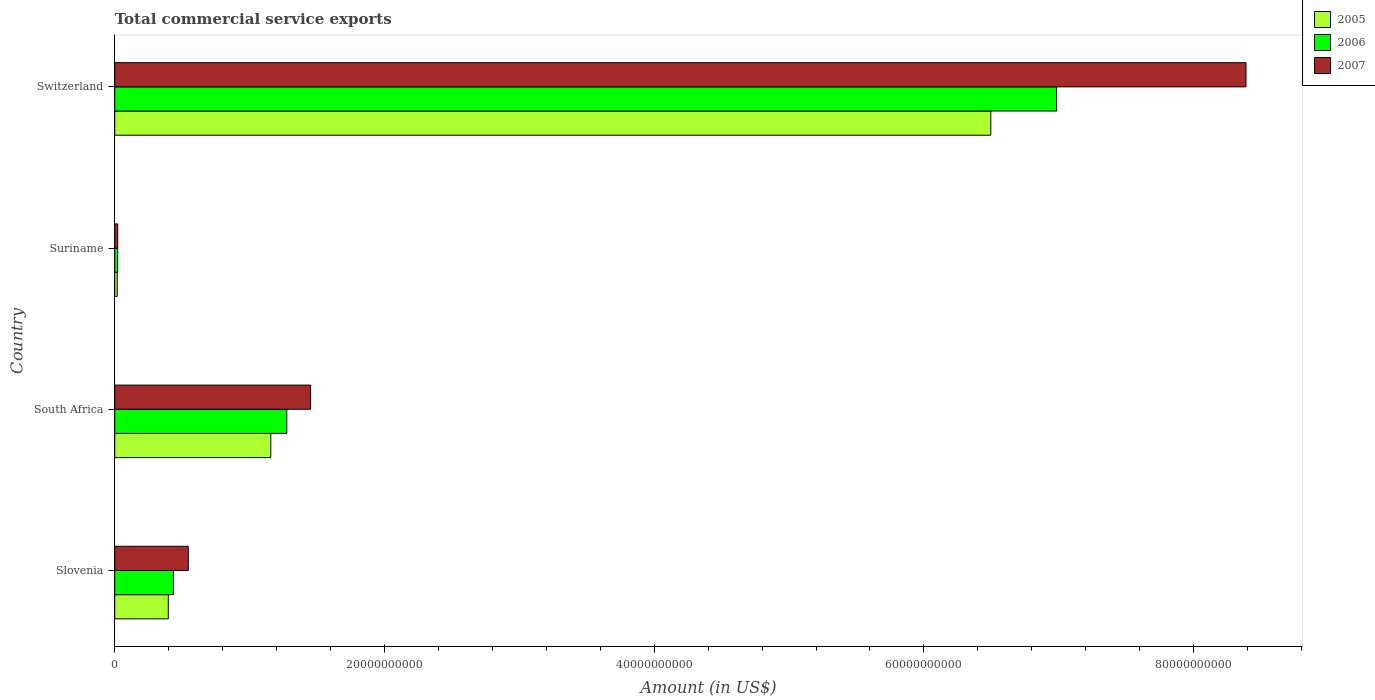How many different coloured bars are there?
Provide a succinct answer. 3. How many groups of bars are there?
Make the answer very short. 4. Are the number of bars on each tick of the Y-axis equal?
Provide a short and direct response. Yes. What is the label of the 2nd group of bars from the top?
Ensure brevity in your answer.  Suriname. What is the total commercial service exports in 2007 in Switzerland?
Keep it short and to the point. 8.39e+1. Across all countries, what is the maximum total commercial service exports in 2006?
Offer a terse response. 6.98e+1. Across all countries, what is the minimum total commercial service exports in 2007?
Give a very brief answer. 2.19e+08. In which country was the total commercial service exports in 2007 maximum?
Provide a succinct answer. Switzerland. In which country was the total commercial service exports in 2005 minimum?
Offer a terse response. Suriname. What is the total total commercial service exports in 2007 in the graph?
Give a very brief answer. 1.04e+11. What is the difference between the total commercial service exports in 2005 in South Africa and that in Suriname?
Your answer should be compact. 1.14e+1. What is the difference between the total commercial service exports in 2007 in Slovenia and the total commercial service exports in 2005 in Suriname?
Your response must be concise. 5.27e+09. What is the average total commercial service exports in 2006 per country?
Offer a very short reply. 2.18e+1. What is the difference between the total commercial service exports in 2006 and total commercial service exports in 2007 in Suriname?
Offer a terse response. -5.10e+06. In how many countries, is the total commercial service exports in 2007 greater than 20000000000 US$?
Offer a terse response. 1. What is the ratio of the total commercial service exports in 2007 in Suriname to that in Switzerland?
Offer a terse response. 0. Is the total commercial service exports in 2007 in Slovenia less than that in Switzerland?
Your answer should be compact. Yes. Is the difference between the total commercial service exports in 2006 in Slovenia and Switzerland greater than the difference between the total commercial service exports in 2007 in Slovenia and Switzerland?
Provide a succinct answer. Yes. What is the difference between the highest and the second highest total commercial service exports in 2005?
Your answer should be compact. 5.34e+1. What is the difference between the highest and the lowest total commercial service exports in 2007?
Offer a terse response. 8.37e+1. In how many countries, is the total commercial service exports in 2005 greater than the average total commercial service exports in 2005 taken over all countries?
Your answer should be very brief. 1. Is the sum of the total commercial service exports in 2005 in Suriname and Switzerland greater than the maximum total commercial service exports in 2007 across all countries?
Your answer should be compact. No. What does the 1st bar from the top in Suriname represents?
Give a very brief answer. 2007. What does the 2nd bar from the bottom in Slovenia represents?
Ensure brevity in your answer.  2006. What is the difference between two consecutive major ticks on the X-axis?
Your response must be concise. 2.00e+1. Does the graph contain any zero values?
Make the answer very short. No. Does the graph contain grids?
Give a very brief answer. No. Where does the legend appear in the graph?
Keep it short and to the point. Top right. How are the legend labels stacked?
Give a very brief answer. Vertical. What is the title of the graph?
Provide a short and direct response. Total commercial service exports. Does "1994" appear as one of the legend labels in the graph?
Keep it short and to the point. No. What is the Amount (in US$) in 2005 in Slovenia?
Offer a terse response. 3.97e+09. What is the Amount (in US$) of 2006 in Slovenia?
Your answer should be compact. 4.35e+09. What is the Amount (in US$) of 2007 in Slovenia?
Give a very brief answer. 5.45e+09. What is the Amount (in US$) of 2005 in South Africa?
Provide a short and direct response. 1.16e+1. What is the Amount (in US$) of 2006 in South Africa?
Your answer should be very brief. 1.28e+1. What is the Amount (in US$) in 2007 in South Africa?
Give a very brief answer. 1.45e+1. What is the Amount (in US$) in 2005 in Suriname?
Offer a terse response. 1.83e+08. What is the Amount (in US$) of 2006 in Suriname?
Offer a very short reply. 2.14e+08. What is the Amount (in US$) in 2007 in Suriname?
Your answer should be very brief. 2.19e+08. What is the Amount (in US$) of 2005 in Switzerland?
Give a very brief answer. 6.50e+1. What is the Amount (in US$) in 2006 in Switzerland?
Provide a short and direct response. 6.98e+1. What is the Amount (in US$) of 2007 in Switzerland?
Make the answer very short. 8.39e+1. Across all countries, what is the maximum Amount (in US$) of 2005?
Make the answer very short. 6.50e+1. Across all countries, what is the maximum Amount (in US$) in 2006?
Give a very brief answer. 6.98e+1. Across all countries, what is the maximum Amount (in US$) in 2007?
Make the answer very short. 8.39e+1. Across all countries, what is the minimum Amount (in US$) in 2005?
Ensure brevity in your answer.  1.83e+08. Across all countries, what is the minimum Amount (in US$) in 2006?
Make the answer very short. 2.14e+08. Across all countries, what is the minimum Amount (in US$) in 2007?
Ensure brevity in your answer.  2.19e+08. What is the total Amount (in US$) of 2005 in the graph?
Ensure brevity in your answer.  8.07e+1. What is the total Amount (in US$) in 2006 in the graph?
Keep it short and to the point. 8.72e+1. What is the total Amount (in US$) in 2007 in the graph?
Make the answer very short. 1.04e+11. What is the difference between the Amount (in US$) of 2005 in Slovenia and that in South Africa?
Keep it short and to the point. -7.60e+09. What is the difference between the Amount (in US$) of 2006 in Slovenia and that in South Africa?
Provide a succinct answer. -8.41e+09. What is the difference between the Amount (in US$) of 2007 in Slovenia and that in South Africa?
Your answer should be compact. -9.07e+09. What is the difference between the Amount (in US$) in 2005 in Slovenia and that in Suriname?
Your answer should be very brief. 3.79e+09. What is the difference between the Amount (in US$) of 2006 in Slovenia and that in Suriname?
Make the answer very short. 4.14e+09. What is the difference between the Amount (in US$) in 2007 in Slovenia and that in Suriname?
Provide a short and direct response. 5.23e+09. What is the difference between the Amount (in US$) in 2005 in Slovenia and that in Switzerland?
Keep it short and to the point. -6.10e+1. What is the difference between the Amount (in US$) in 2006 in Slovenia and that in Switzerland?
Your answer should be compact. -6.55e+1. What is the difference between the Amount (in US$) of 2007 in Slovenia and that in Switzerland?
Make the answer very short. -7.84e+1. What is the difference between the Amount (in US$) of 2005 in South Africa and that in Suriname?
Offer a terse response. 1.14e+1. What is the difference between the Amount (in US$) of 2006 in South Africa and that in Suriname?
Offer a very short reply. 1.25e+1. What is the difference between the Amount (in US$) in 2007 in South Africa and that in Suriname?
Offer a terse response. 1.43e+1. What is the difference between the Amount (in US$) of 2005 in South Africa and that in Switzerland?
Keep it short and to the point. -5.34e+1. What is the difference between the Amount (in US$) in 2006 in South Africa and that in Switzerland?
Ensure brevity in your answer.  -5.71e+1. What is the difference between the Amount (in US$) of 2007 in South Africa and that in Switzerland?
Make the answer very short. -6.94e+1. What is the difference between the Amount (in US$) in 2005 in Suriname and that in Switzerland?
Make the answer very short. -6.48e+1. What is the difference between the Amount (in US$) of 2006 in Suriname and that in Switzerland?
Your answer should be very brief. -6.96e+1. What is the difference between the Amount (in US$) in 2007 in Suriname and that in Switzerland?
Offer a very short reply. -8.37e+1. What is the difference between the Amount (in US$) of 2005 in Slovenia and the Amount (in US$) of 2006 in South Africa?
Your answer should be very brief. -8.79e+09. What is the difference between the Amount (in US$) of 2005 in Slovenia and the Amount (in US$) of 2007 in South Africa?
Your answer should be very brief. -1.05e+1. What is the difference between the Amount (in US$) of 2006 in Slovenia and the Amount (in US$) of 2007 in South Africa?
Your response must be concise. -1.02e+1. What is the difference between the Amount (in US$) in 2005 in Slovenia and the Amount (in US$) in 2006 in Suriname?
Keep it short and to the point. 3.76e+09. What is the difference between the Amount (in US$) in 2005 in Slovenia and the Amount (in US$) in 2007 in Suriname?
Make the answer very short. 3.75e+09. What is the difference between the Amount (in US$) of 2006 in Slovenia and the Amount (in US$) of 2007 in Suriname?
Provide a succinct answer. 4.13e+09. What is the difference between the Amount (in US$) of 2005 in Slovenia and the Amount (in US$) of 2006 in Switzerland?
Provide a short and direct response. -6.59e+1. What is the difference between the Amount (in US$) of 2005 in Slovenia and the Amount (in US$) of 2007 in Switzerland?
Keep it short and to the point. -7.99e+1. What is the difference between the Amount (in US$) of 2006 in Slovenia and the Amount (in US$) of 2007 in Switzerland?
Provide a short and direct response. -7.95e+1. What is the difference between the Amount (in US$) in 2005 in South Africa and the Amount (in US$) in 2006 in Suriname?
Give a very brief answer. 1.14e+1. What is the difference between the Amount (in US$) of 2005 in South Africa and the Amount (in US$) of 2007 in Suriname?
Your response must be concise. 1.14e+1. What is the difference between the Amount (in US$) in 2006 in South Africa and the Amount (in US$) in 2007 in Suriname?
Ensure brevity in your answer.  1.25e+1. What is the difference between the Amount (in US$) in 2005 in South Africa and the Amount (in US$) in 2006 in Switzerland?
Ensure brevity in your answer.  -5.83e+1. What is the difference between the Amount (in US$) of 2005 in South Africa and the Amount (in US$) of 2007 in Switzerland?
Offer a terse response. -7.23e+1. What is the difference between the Amount (in US$) of 2006 in South Africa and the Amount (in US$) of 2007 in Switzerland?
Provide a succinct answer. -7.11e+1. What is the difference between the Amount (in US$) in 2005 in Suriname and the Amount (in US$) in 2006 in Switzerland?
Your answer should be very brief. -6.97e+1. What is the difference between the Amount (in US$) in 2005 in Suriname and the Amount (in US$) in 2007 in Switzerland?
Provide a short and direct response. -8.37e+1. What is the difference between the Amount (in US$) in 2006 in Suriname and the Amount (in US$) in 2007 in Switzerland?
Offer a terse response. -8.37e+1. What is the average Amount (in US$) in 2005 per country?
Keep it short and to the point. 2.02e+1. What is the average Amount (in US$) of 2006 per country?
Your answer should be very brief. 2.18e+1. What is the average Amount (in US$) in 2007 per country?
Your answer should be compact. 2.60e+1. What is the difference between the Amount (in US$) in 2005 and Amount (in US$) in 2006 in Slovenia?
Provide a succinct answer. -3.80e+08. What is the difference between the Amount (in US$) of 2005 and Amount (in US$) of 2007 in Slovenia?
Your answer should be compact. -1.48e+09. What is the difference between the Amount (in US$) of 2006 and Amount (in US$) of 2007 in Slovenia?
Your answer should be compact. -1.10e+09. What is the difference between the Amount (in US$) in 2005 and Amount (in US$) in 2006 in South Africa?
Make the answer very short. -1.19e+09. What is the difference between the Amount (in US$) of 2005 and Amount (in US$) of 2007 in South Africa?
Give a very brief answer. -2.95e+09. What is the difference between the Amount (in US$) of 2006 and Amount (in US$) of 2007 in South Africa?
Your answer should be very brief. -1.76e+09. What is the difference between the Amount (in US$) of 2005 and Amount (in US$) of 2006 in Suriname?
Ensure brevity in your answer.  -3.10e+07. What is the difference between the Amount (in US$) in 2005 and Amount (in US$) in 2007 in Suriname?
Give a very brief answer. -3.61e+07. What is the difference between the Amount (in US$) of 2006 and Amount (in US$) of 2007 in Suriname?
Your answer should be very brief. -5.10e+06. What is the difference between the Amount (in US$) of 2005 and Amount (in US$) of 2006 in Switzerland?
Give a very brief answer. -4.88e+09. What is the difference between the Amount (in US$) in 2005 and Amount (in US$) in 2007 in Switzerland?
Your answer should be compact. -1.89e+1. What is the difference between the Amount (in US$) of 2006 and Amount (in US$) of 2007 in Switzerland?
Make the answer very short. -1.40e+1. What is the ratio of the Amount (in US$) in 2005 in Slovenia to that in South Africa?
Offer a terse response. 0.34. What is the ratio of the Amount (in US$) of 2006 in Slovenia to that in South Africa?
Your answer should be compact. 0.34. What is the ratio of the Amount (in US$) in 2007 in Slovenia to that in South Africa?
Keep it short and to the point. 0.38. What is the ratio of the Amount (in US$) in 2005 in Slovenia to that in Suriname?
Provide a short and direct response. 21.74. What is the ratio of the Amount (in US$) of 2006 in Slovenia to that in Suriname?
Your answer should be very brief. 20.36. What is the ratio of the Amount (in US$) of 2007 in Slovenia to that in Suriname?
Offer a very short reply. 24.92. What is the ratio of the Amount (in US$) in 2005 in Slovenia to that in Switzerland?
Offer a very short reply. 0.06. What is the ratio of the Amount (in US$) in 2006 in Slovenia to that in Switzerland?
Offer a terse response. 0.06. What is the ratio of the Amount (in US$) of 2007 in Slovenia to that in Switzerland?
Keep it short and to the point. 0.07. What is the ratio of the Amount (in US$) of 2005 in South Africa to that in Suriname?
Provide a short and direct response. 63.36. What is the ratio of the Amount (in US$) in 2006 in South Africa to that in Suriname?
Provide a short and direct response. 59.72. What is the ratio of the Amount (in US$) in 2007 in South Africa to that in Suriname?
Offer a very short reply. 66.39. What is the ratio of the Amount (in US$) of 2005 in South Africa to that in Switzerland?
Give a very brief answer. 0.18. What is the ratio of the Amount (in US$) of 2006 in South Africa to that in Switzerland?
Your answer should be compact. 0.18. What is the ratio of the Amount (in US$) of 2007 in South Africa to that in Switzerland?
Keep it short and to the point. 0.17. What is the ratio of the Amount (in US$) in 2005 in Suriname to that in Switzerland?
Give a very brief answer. 0. What is the ratio of the Amount (in US$) of 2006 in Suriname to that in Switzerland?
Offer a very short reply. 0. What is the ratio of the Amount (in US$) in 2007 in Suriname to that in Switzerland?
Make the answer very short. 0. What is the difference between the highest and the second highest Amount (in US$) of 2005?
Provide a succinct answer. 5.34e+1. What is the difference between the highest and the second highest Amount (in US$) in 2006?
Your answer should be very brief. 5.71e+1. What is the difference between the highest and the second highest Amount (in US$) of 2007?
Your answer should be very brief. 6.94e+1. What is the difference between the highest and the lowest Amount (in US$) in 2005?
Your answer should be very brief. 6.48e+1. What is the difference between the highest and the lowest Amount (in US$) of 2006?
Provide a short and direct response. 6.96e+1. What is the difference between the highest and the lowest Amount (in US$) of 2007?
Your response must be concise. 8.37e+1. 